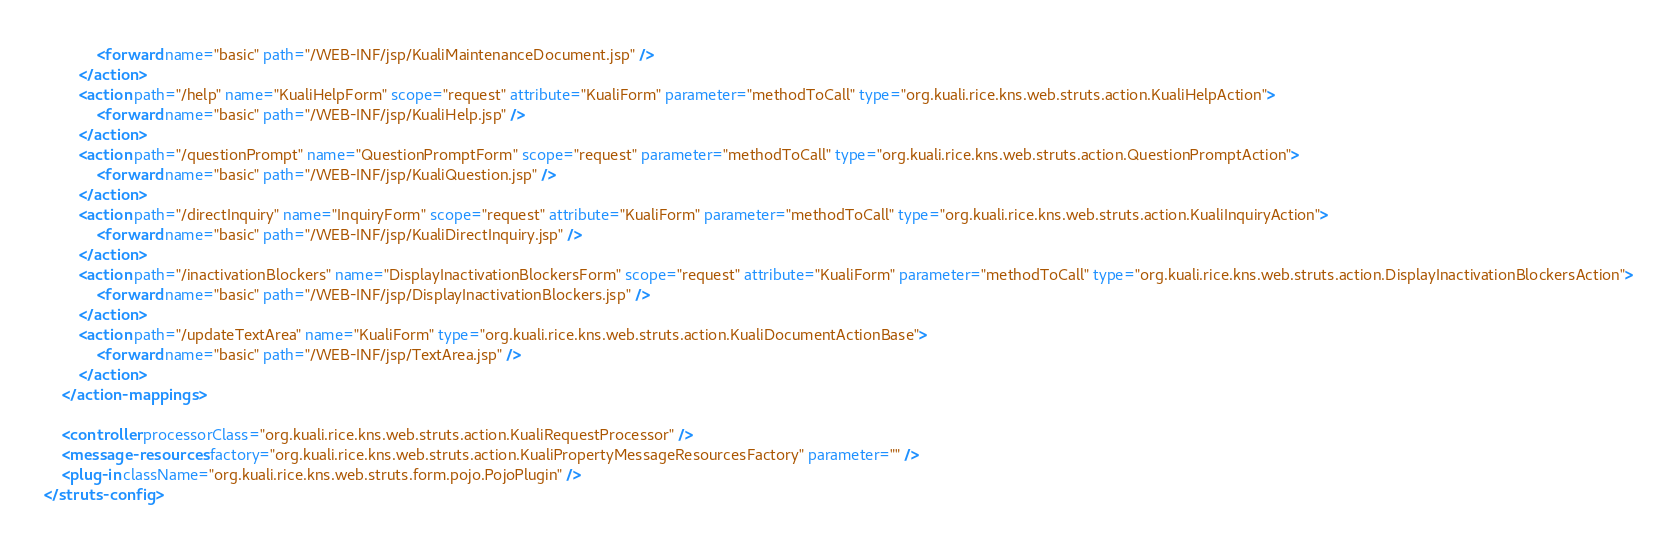<code> <loc_0><loc_0><loc_500><loc_500><_XML_>	        <forward name="basic" path="/WEB-INF/jsp/KualiMaintenanceDocument.jsp" />
	    </action>    
	    <action path="/help" name="KualiHelpForm" scope="request" attribute="KualiForm" parameter="methodToCall" type="org.kuali.rice.kns.web.struts.action.KualiHelpAction">
	        <forward name="basic" path="/WEB-INF/jsp/KualiHelp.jsp" />
	    </action>
        <action path="/questionPrompt" name="QuestionPromptForm" scope="request" parameter="methodToCall" type="org.kuali.rice.kns.web.struts.action.QuestionPromptAction">
            <forward name="basic" path="/WEB-INF/jsp/KualiQuestion.jsp" />
        </action>
	    <action path="/directInquiry" name="InquiryForm" scope="request" attribute="KualiForm" parameter="methodToCall" type="org.kuali.rice.kns.web.struts.action.KualiInquiryAction">
	        <forward name="basic" path="/WEB-INF/jsp/KualiDirectInquiry.jsp" />
	    </action>
	    <action path="/inactivationBlockers" name="DisplayInactivationBlockersForm" scope="request" attribute="KualiForm" parameter="methodToCall" type="org.kuali.rice.kns.web.struts.action.DisplayInactivationBlockersAction">
	        <forward name="basic" path="/WEB-INF/jsp/DisplayInactivationBlockers.jsp" />
	    </action>
        <action path="/updateTextArea" name="KualiForm" type="org.kuali.rice.kns.web.struts.action.KualiDocumentActionBase">
            <forward name="basic" path="/WEB-INF/jsp/TextArea.jsp" />
        </action>
    </action-mappings>

    <controller processorClass="org.kuali.rice.kns.web.struts.action.KualiRequestProcessor" />
    <message-resources factory="org.kuali.rice.kns.web.struts.action.KualiPropertyMessageResourcesFactory" parameter="" />
    <plug-in className="org.kuali.rice.kns.web.struts.form.pojo.PojoPlugin" />
</struts-config>

</code> 